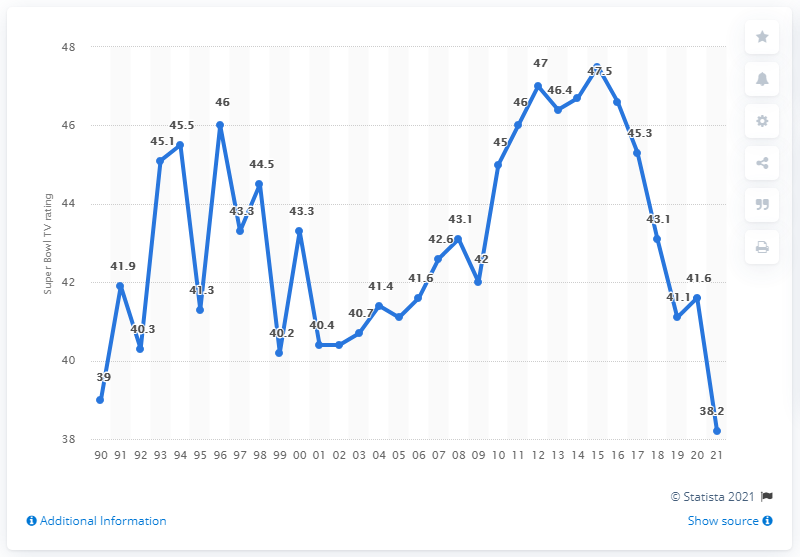Specify some key components in this picture. The Tampa Bay Buccaneers' television rating in 2021 was 38.2. 